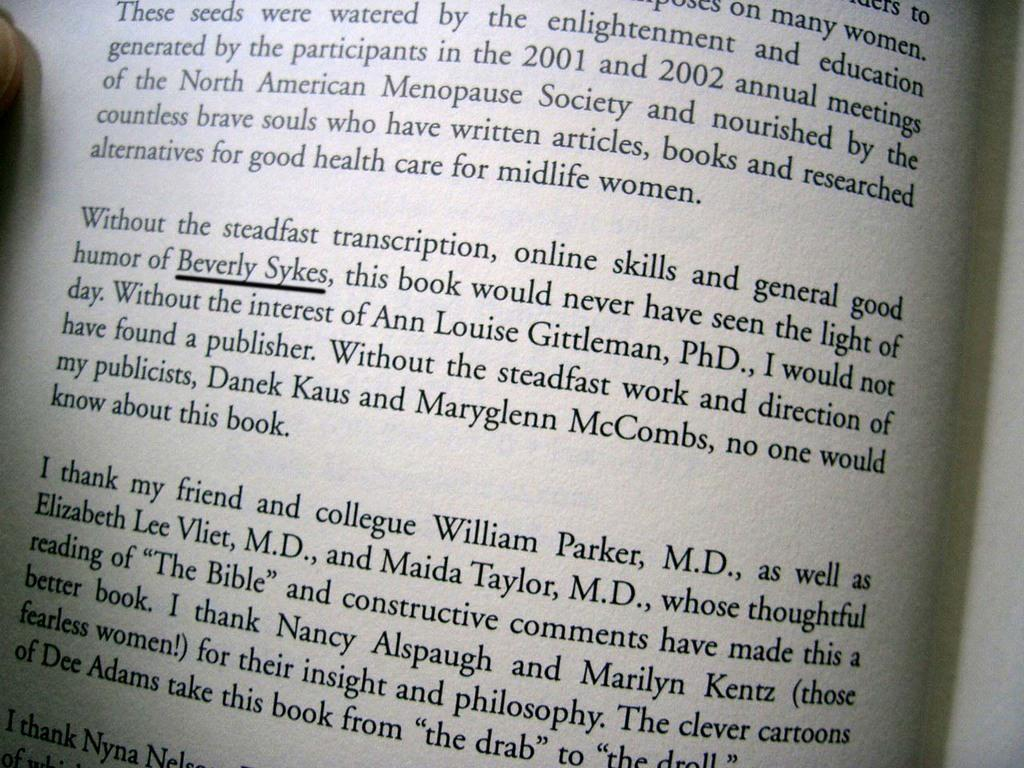<image>
Render a clear and concise summary of the photo. An open book with the name "Beverly Sykes" underlined. 